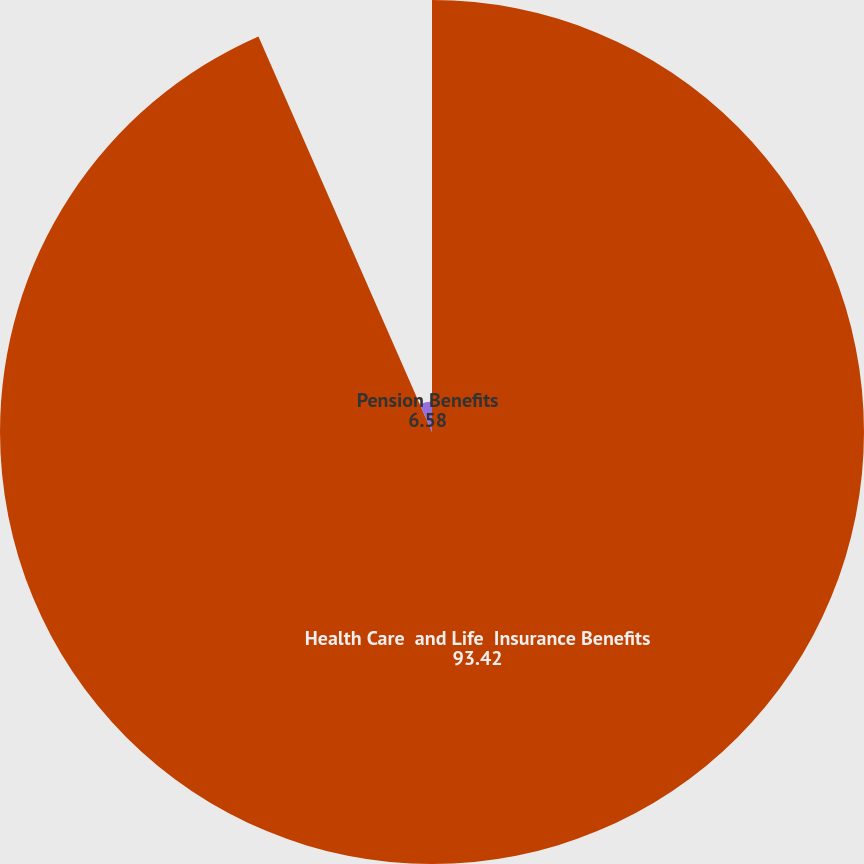Convert chart. <chart><loc_0><loc_0><loc_500><loc_500><pie_chart><fcel>Health Care  and Life  Insurance Benefits<fcel>Pension Benefits<nl><fcel>93.42%<fcel>6.58%<nl></chart> 